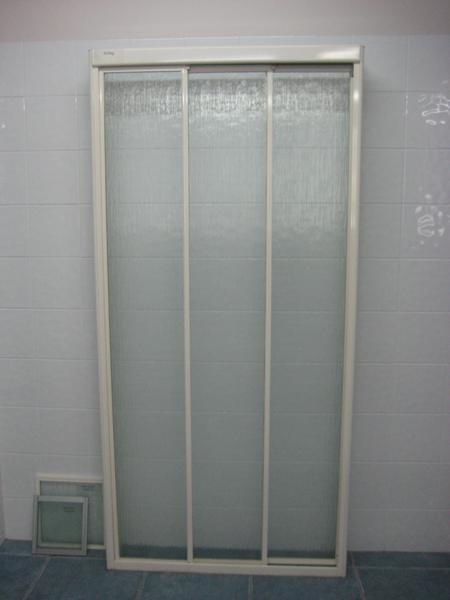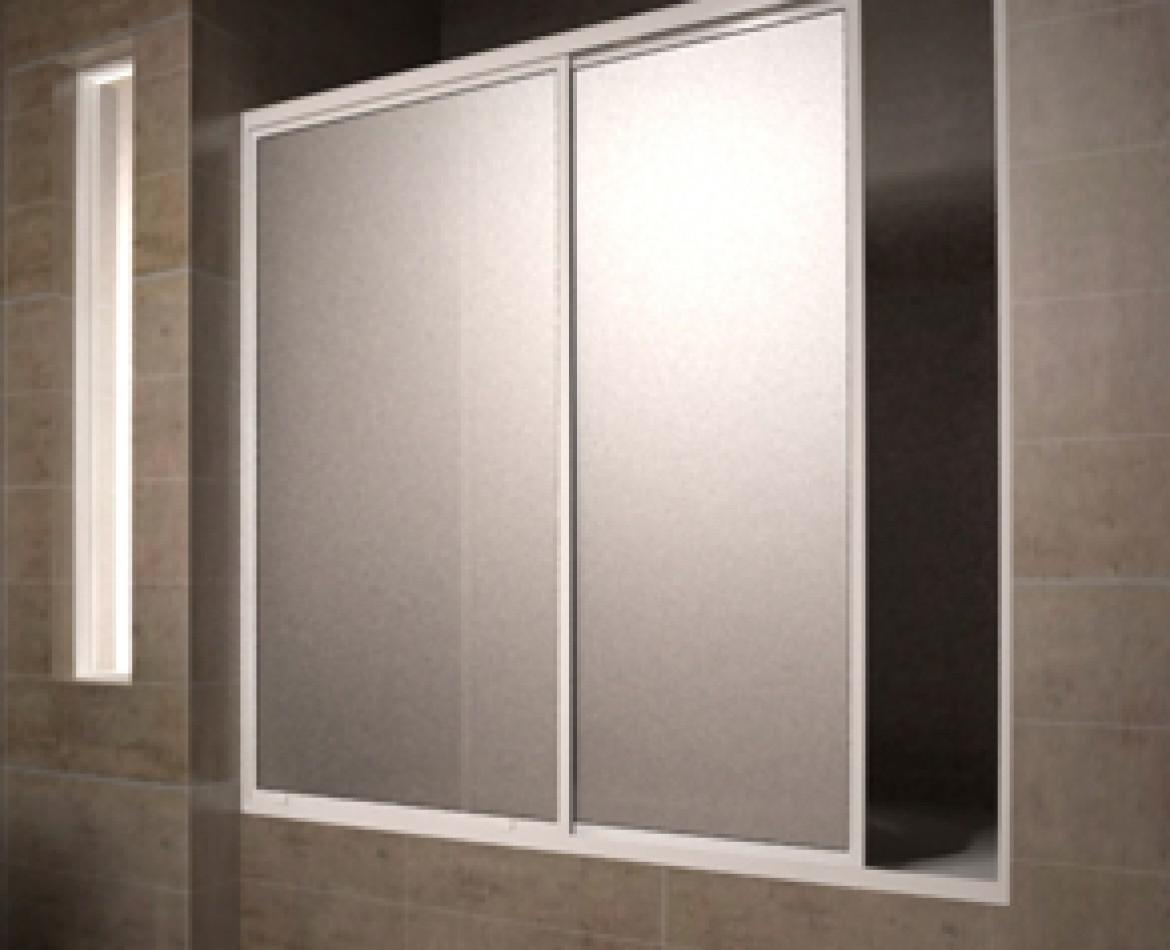The first image is the image on the left, the second image is the image on the right. For the images displayed, is the sentence "An image shows a two door dimensional unit with a white front." factually correct? Answer yes or no. No. 